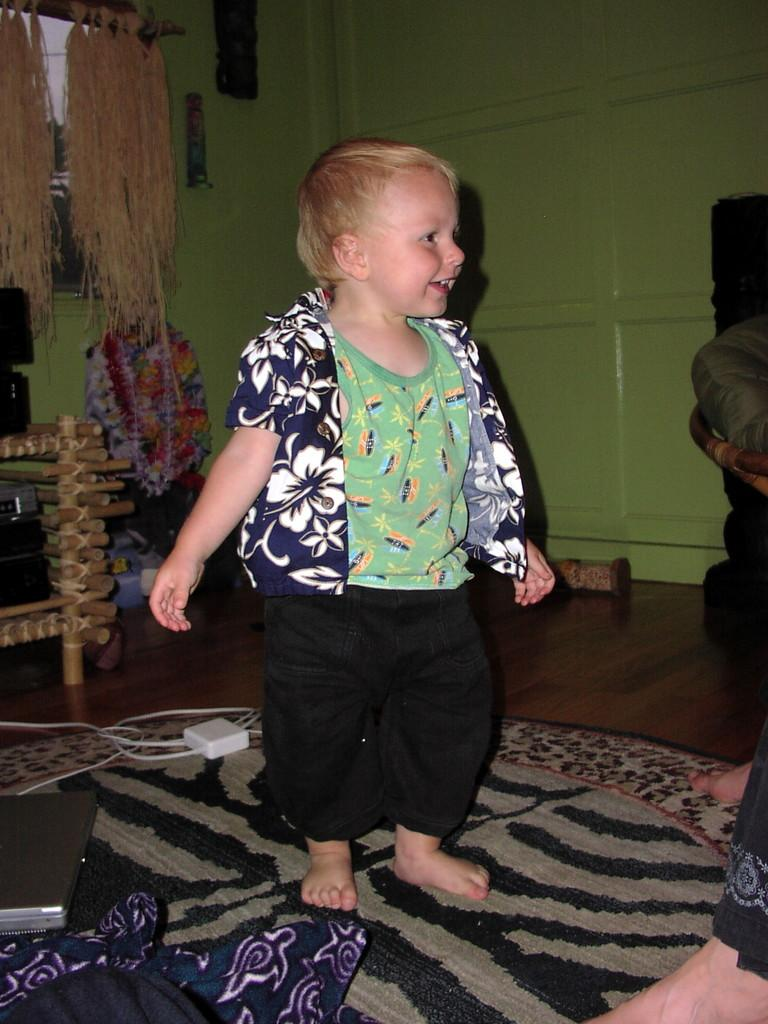What is the boy doing in the image? The boy is standing on a carpet in the image. Can you describe the person in front of the boy? There are legs of a person visible in front of the boy. What electronic device is present in the image? A laptop is present on the side of the image. What type of items are made of cloth in the image? There are cloth items in the image. What other objects can be seen in the image besides the ones mentioned? There are other objects visible in the image. What decision does the boy make in the image? There is no indication of a decision being made by the boy in the image. 